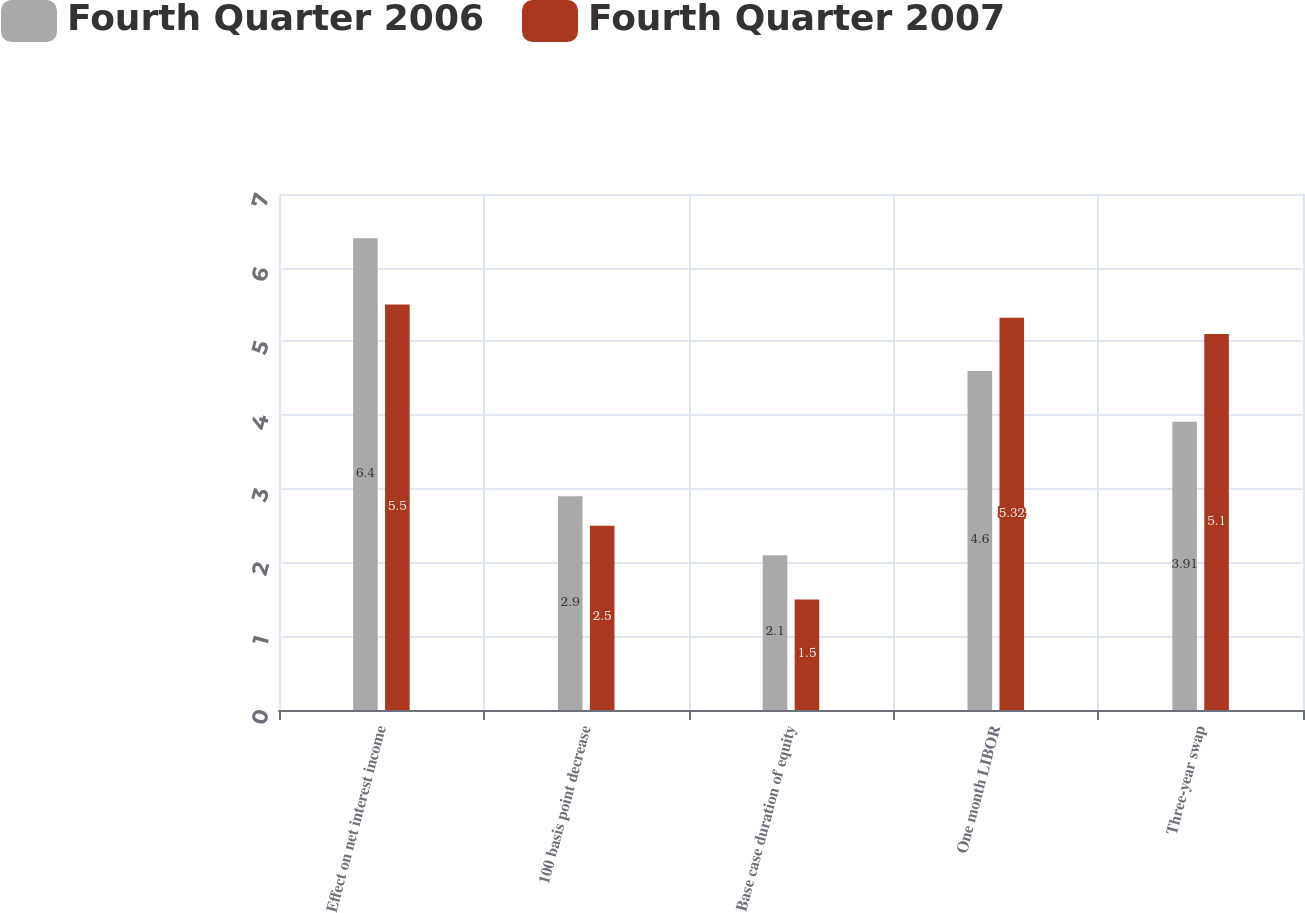Convert chart. <chart><loc_0><loc_0><loc_500><loc_500><stacked_bar_chart><ecel><fcel>Effect on net interest income<fcel>100 basis point decrease<fcel>Base case duration of equity<fcel>One month LIBOR<fcel>Three-year swap<nl><fcel>Fourth Quarter 2006<fcel>6.4<fcel>2.9<fcel>2.1<fcel>4.6<fcel>3.91<nl><fcel>Fourth Quarter 2007<fcel>5.5<fcel>2.5<fcel>1.5<fcel>5.32<fcel>5.1<nl></chart> 